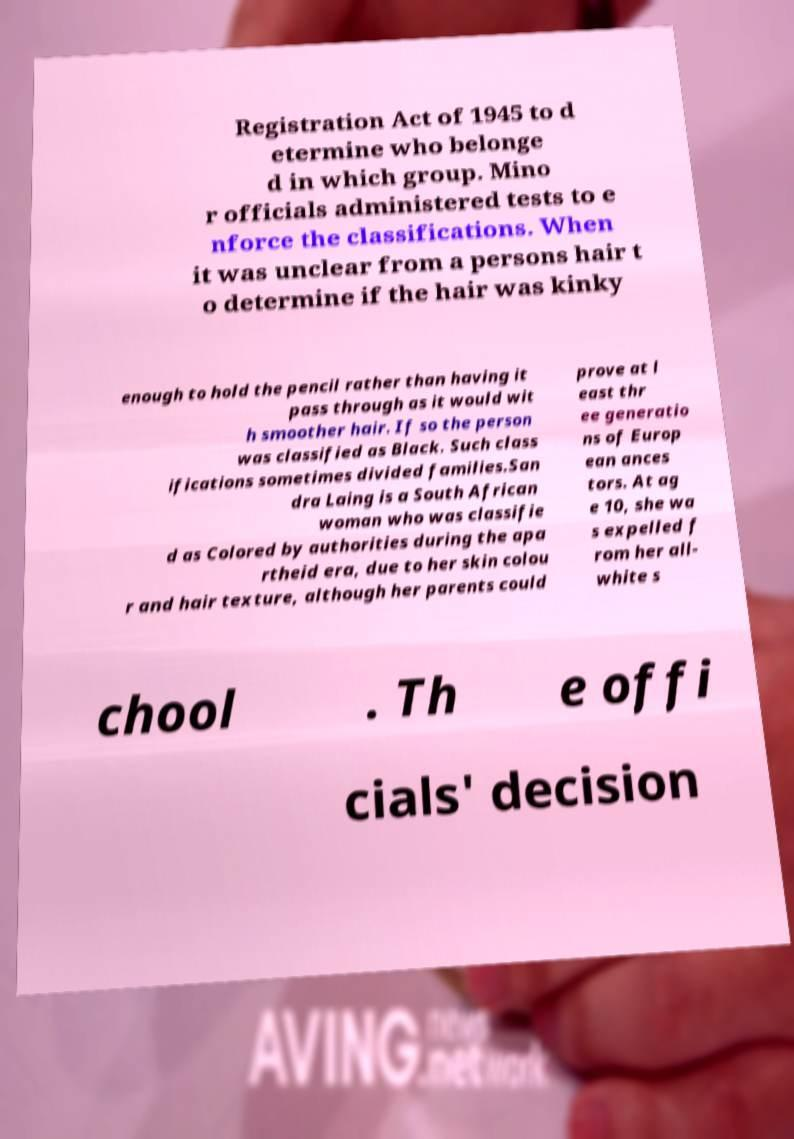There's text embedded in this image that I need extracted. Can you transcribe it verbatim? Registration Act of 1945 to d etermine who belonge d in which group. Mino r officials administered tests to e nforce the classifications. When it was unclear from a persons hair t o determine if the hair was kinky enough to hold the pencil rather than having it pass through as it would wit h smoother hair. If so the person was classified as Black. Such class ifications sometimes divided families.San dra Laing is a South African woman who was classifie d as Colored by authorities during the apa rtheid era, due to her skin colou r and hair texture, although her parents could prove at l east thr ee generatio ns of Europ ean ances tors. At ag e 10, she wa s expelled f rom her all- white s chool . Th e offi cials' decision 